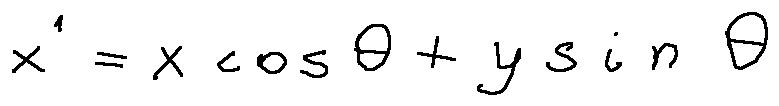Convert formula to latex. <formula><loc_0><loc_0><loc_500><loc_500>x ^ { \prime } = x \cos \theta + y \sin \theta</formula> 